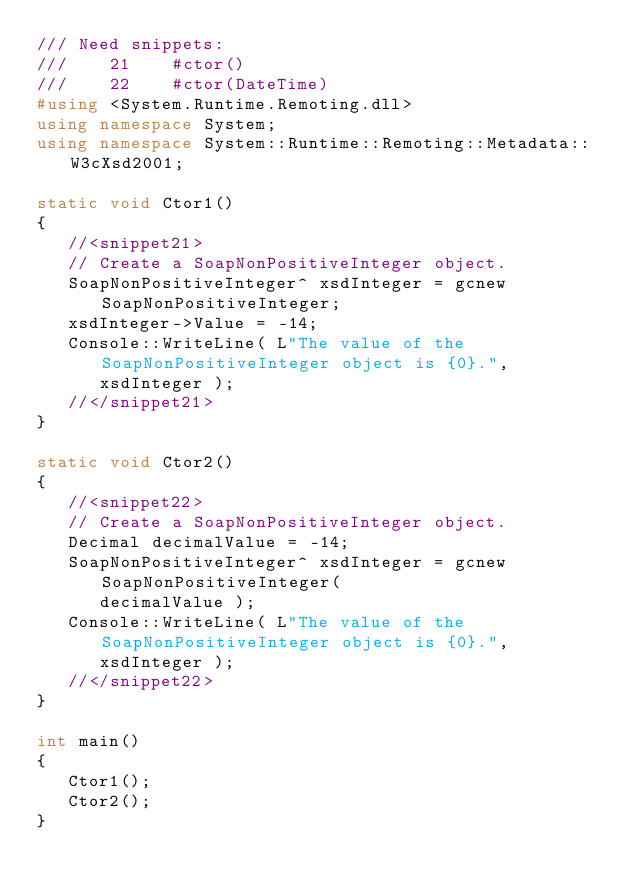<code> <loc_0><loc_0><loc_500><loc_500><_C++_>/// Need snippets:
///    21    #ctor()
///    22    #ctor(DateTime)
#using <System.Runtime.Remoting.dll>
using namespace System;
using namespace System::Runtime::Remoting::Metadata::W3cXsd2001;

static void Ctor1()
{
   //<snippet21>
   // Create a SoapNonPositiveInteger object.
   SoapNonPositiveInteger^ xsdInteger = gcnew SoapNonPositiveInteger;
   xsdInteger->Value = -14;
   Console::WriteLine( L"The value of the SoapNonPositiveInteger object is {0}.",
      xsdInteger );
   //</snippet21>
}

static void Ctor2()
{
   //<snippet22>
   // Create a SoapNonPositiveInteger object.
   Decimal decimalValue = -14;
   SoapNonPositiveInteger^ xsdInteger = gcnew SoapNonPositiveInteger(
      decimalValue );
   Console::WriteLine( L"The value of the SoapNonPositiveInteger object is {0}.",
      xsdInteger );
   //</snippet22>
}

int main()
{
   Ctor1();
   Ctor2();
}

</code> 